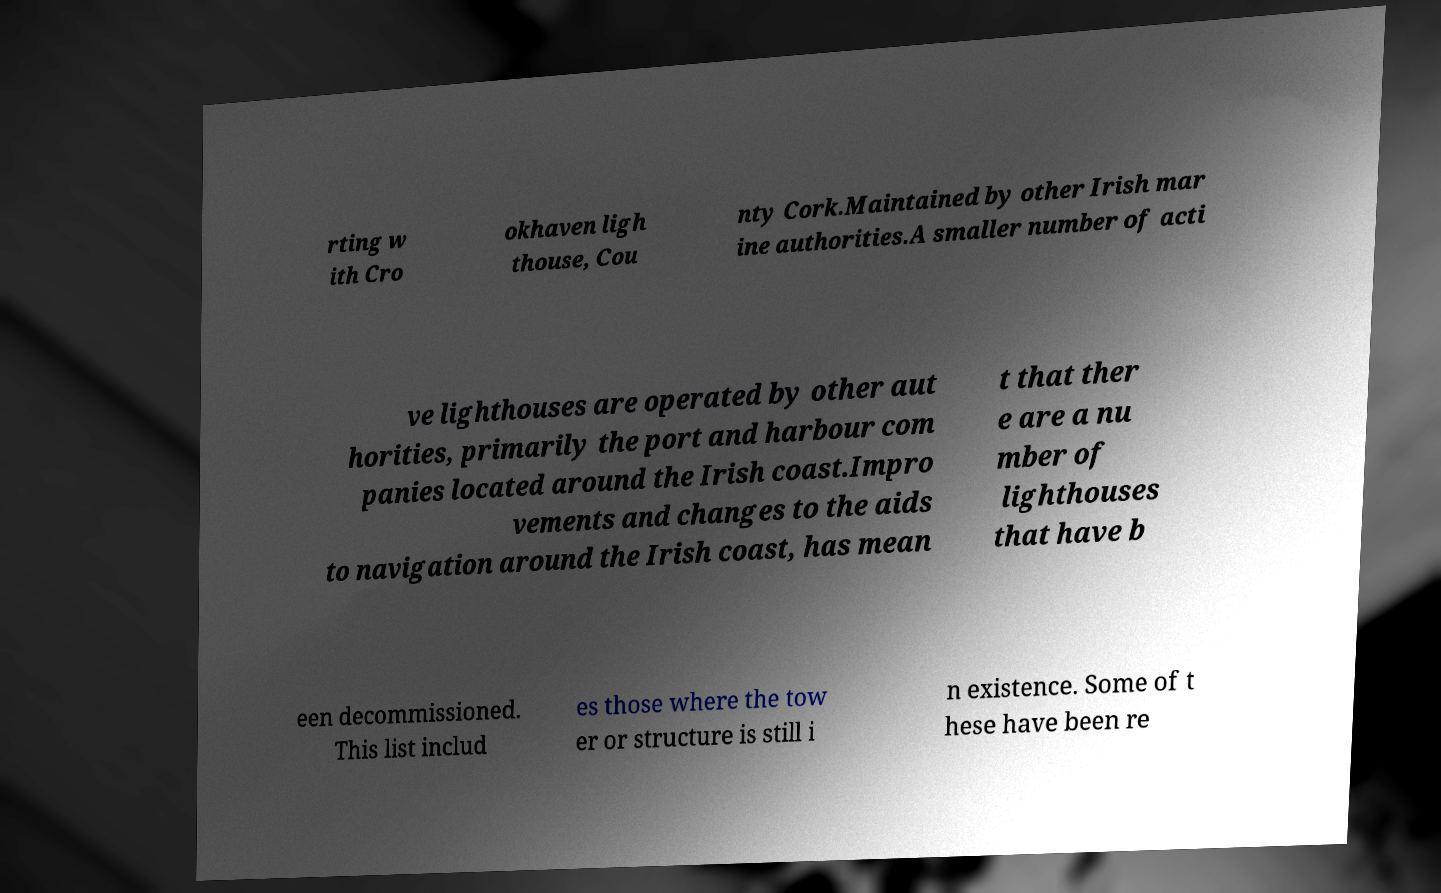What messages or text are displayed in this image? I need them in a readable, typed format. rting w ith Cro okhaven ligh thouse, Cou nty Cork.Maintained by other Irish mar ine authorities.A smaller number of acti ve lighthouses are operated by other aut horities, primarily the port and harbour com panies located around the Irish coast.Impro vements and changes to the aids to navigation around the Irish coast, has mean t that ther e are a nu mber of lighthouses that have b een decommissioned. This list includ es those where the tow er or structure is still i n existence. Some of t hese have been re 